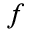Convert formula to latex. <formula><loc_0><loc_0><loc_500><loc_500>f</formula> 